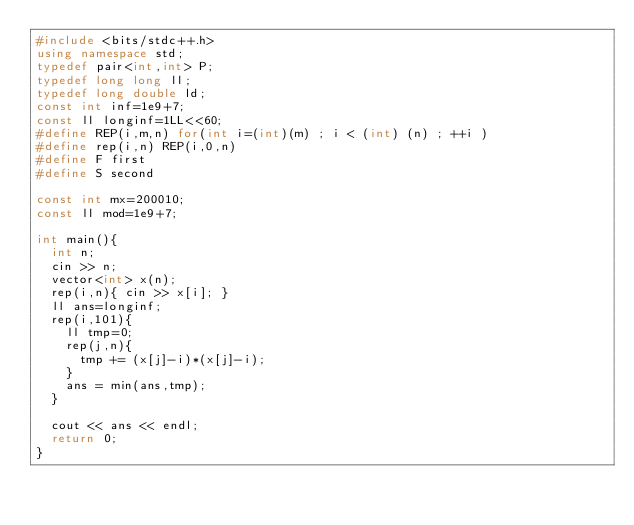<code> <loc_0><loc_0><loc_500><loc_500><_C++_>#include <bits/stdc++.h>
using namespace std;
typedef pair<int,int> P;
typedef long long ll;
typedef long double ld;
const int inf=1e9+7;
const ll longinf=1LL<<60;
#define REP(i,m,n) for(int i=(int)(m) ; i < (int) (n) ; ++i )
#define rep(i,n) REP(i,0,n)
#define F first
#define S second
 
const int mx=200010;
const ll mod=1e9+7;

int main(){
  int n;
  cin >> n;
  vector<int> x(n);
  rep(i,n){ cin >> x[i]; }
  ll ans=longinf;  
  rep(i,101){
    ll tmp=0;
    rep(j,n){
      tmp += (x[j]-i)*(x[j]-i);
    }
    ans = min(ans,tmp);
  }

  cout << ans << endl;
  return 0;
}</code> 